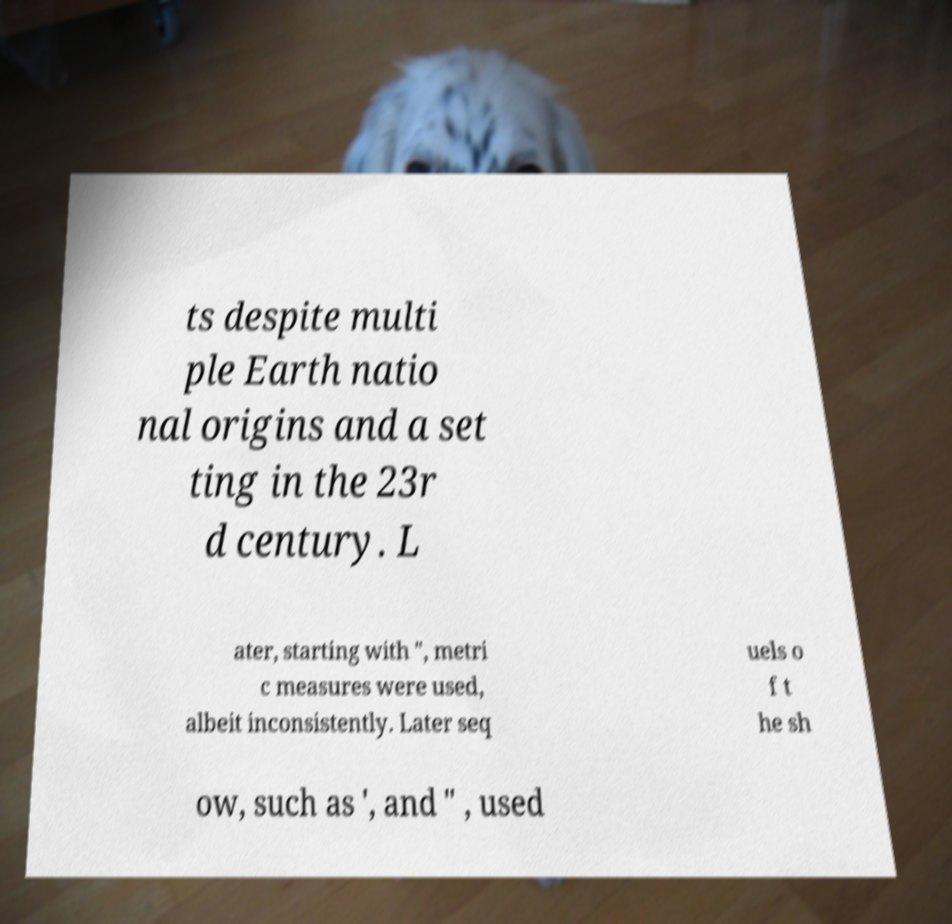What messages or text are displayed in this image? I need them in a readable, typed format. ts despite multi ple Earth natio nal origins and a set ting in the 23r d century. L ater, starting with ", metri c measures were used, albeit inconsistently. Later seq uels o f t he sh ow, such as ', and " , used 